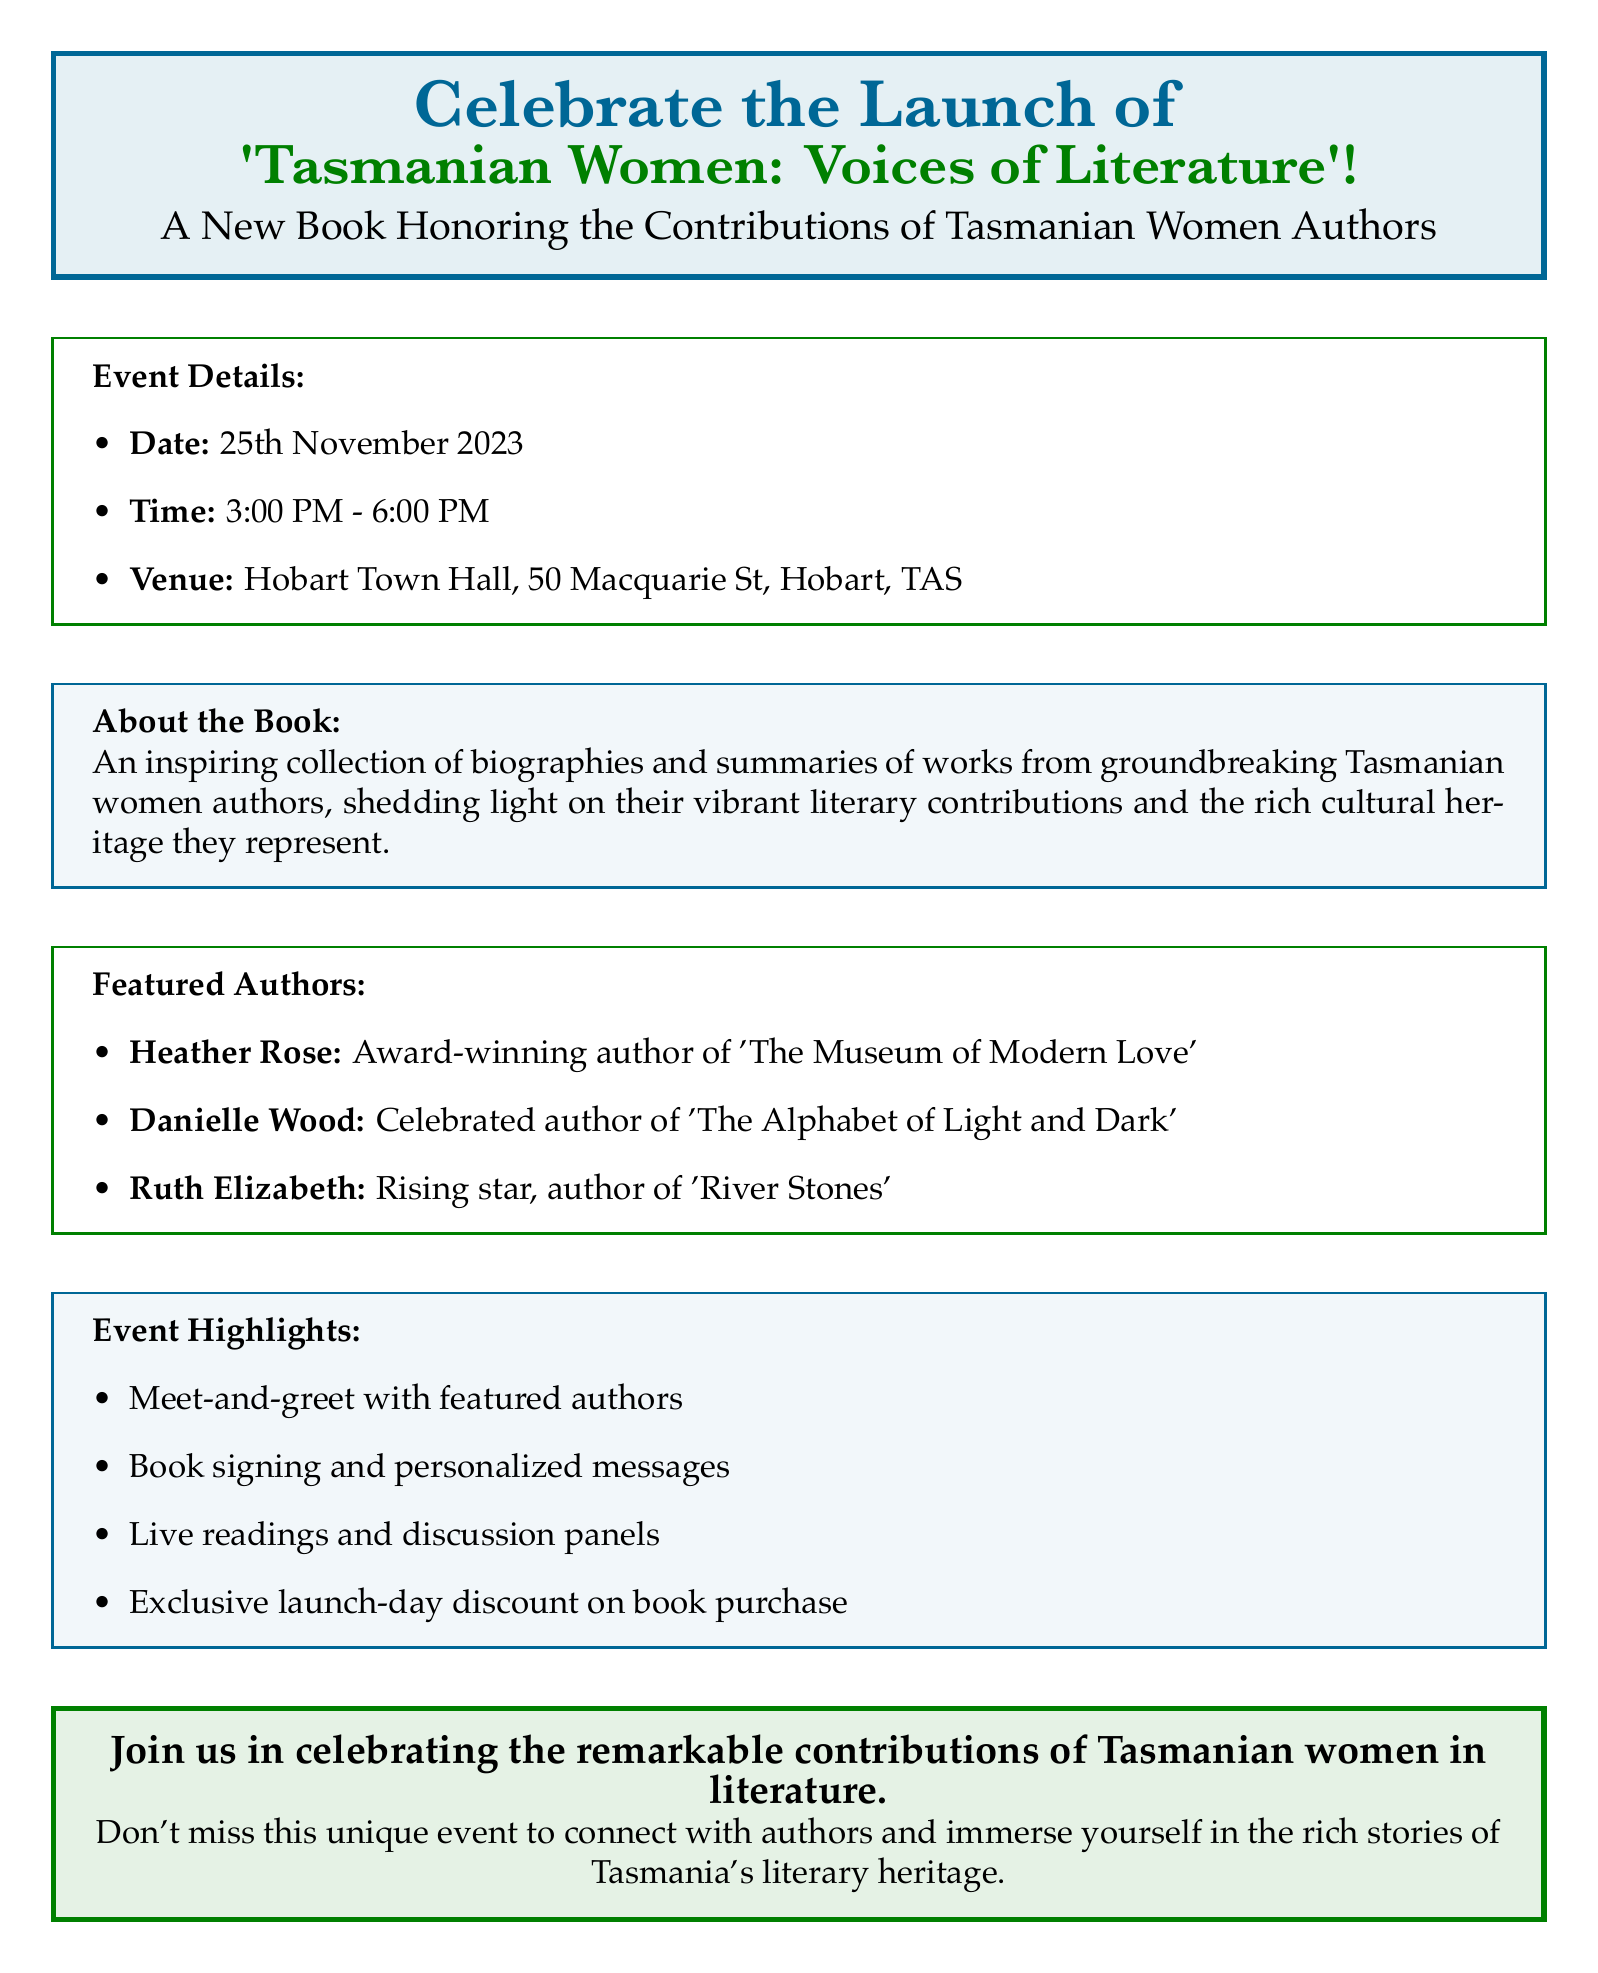What is the name of the book being launched? The book is focused on Tasmanian women authors and is titled 'Tasmanian Women: Voices of Literature'.
Answer: 'Tasmanian Women: Voices of Literature' What date is the book launch scheduled for? The date of the event is explicitly mentioned in the document as the day of the launch.
Answer: 25th November 2023 What is the venue for the event? The document specifies the location where the book launch will take place.
Answer: Hobart Town Hall Who is one of the featured authors? The document lists several authors, and one can be chosen from the provided names.
Answer: Heather Rose What time does the event start? The start time of the event is provided clearly in the details section of the document.
Answer: 3:00 PM What kind of event highlight allows interaction with authors? The document mentions a specific event highlight that involves personal engagement with featured authors.
Answer: Meet-and-greet with featured authors What type of discount is offered during the event? The document states a specific offer available to attendees on the launch day regarding book purchase.
Answer: Exclusive launch-day discount How many authors are featured in the book? The number of authors listed in the document provides a clear answer to this question about the content.
Answer: Three 